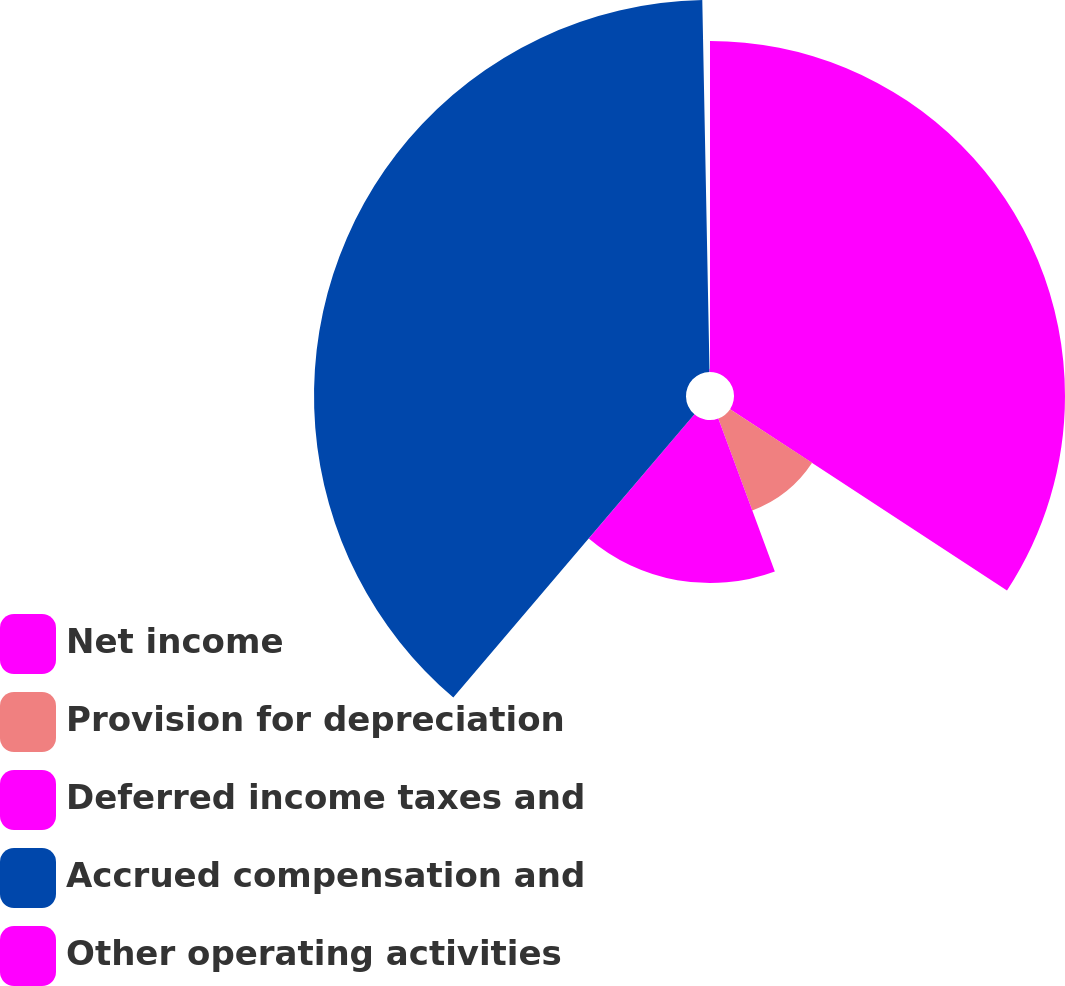<chart> <loc_0><loc_0><loc_500><loc_500><pie_chart><fcel>Net income<fcel>Provision for depreciation<fcel>Deferred income taxes and<fcel>Accrued compensation and<fcel>Other operating activities<nl><fcel>34.23%<fcel>10.14%<fcel>16.86%<fcel>38.47%<fcel>0.31%<nl></chart> 